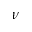<formula> <loc_0><loc_0><loc_500><loc_500>\nu</formula> 